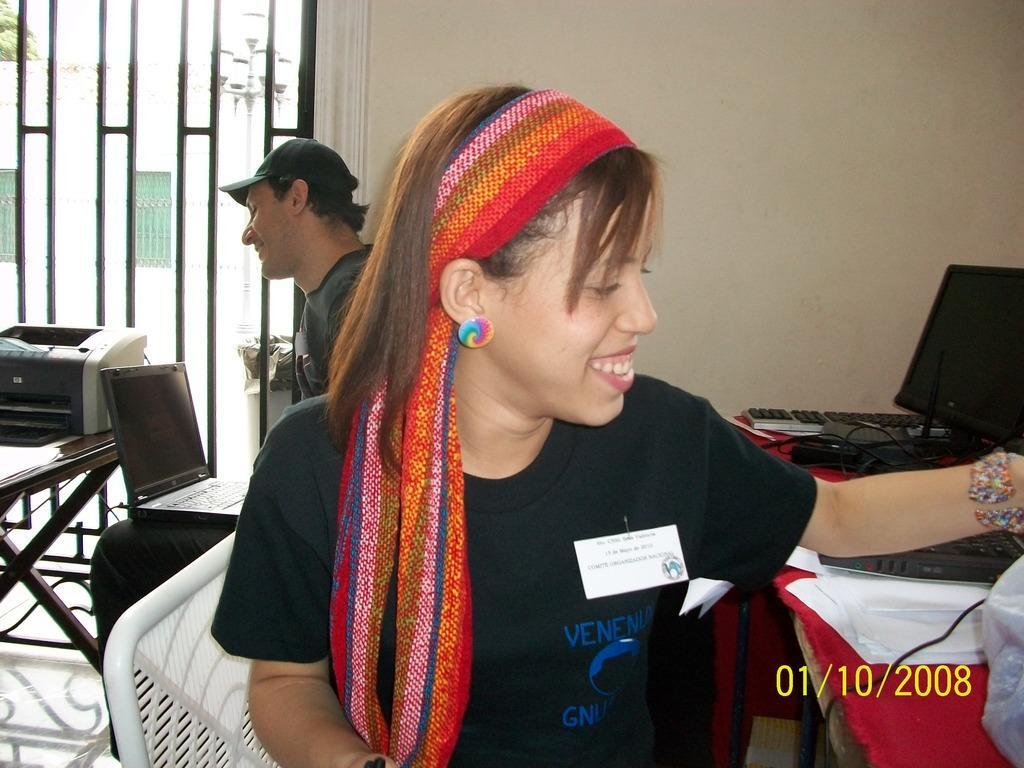Please provide a concise description of this image. In this image I can see a person smiling, wearing a headband and a black t shirt. There are papers, monitor and keyboards on a table, on the right. There is a printer on a table, on the left. A person is sitting at the back and operating a laptop. There is a window at the back. 